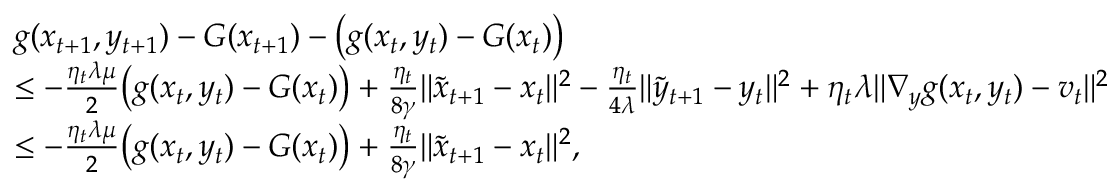Convert formula to latex. <formula><loc_0><loc_0><loc_500><loc_500>\begin{array} { r l } & { g ( x _ { t + 1 } , y _ { t + 1 } ) - G ( x _ { t + 1 } ) - \left ( g ( x _ { t } , y _ { t } ) - G ( x _ { t } ) \right ) } \\ & { \leq - \frac { \eta _ { t } \lambda \mu } { 2 } \left ( g ( x _ { t } , y _ { t } ) - G ( x _ { t } ) \right ) + \frac { \eta _ { t } } { 8 \gamma } \| \tilde { x } _ { t + 1 } - x _ { t } \| ^ { 2 } - \frac { \eta _ { t } } { 4 \lambda } \| \tilde { y } _ { t + 1 } - y _ { t } \| ^ { 2 } + \eta _ { t } \lambda \| \nabla _ { y } g ( x _ { t } , y _ { t } ) - v _ { t } \| ^ { 2 } } \\ & { \leq - \frac { \eta _ { t } \lambda \mu } { 2 } \left ( g ( x _ { t } , y _ { t } ) - G ( x _ { t } ) \right ) + \frac { \eta _ { t } } { 8 \gamma } \| \tilde { x } _ { t + 1 } - x _ { t } \| ^ { 2 } , } \end{array}</formula> 